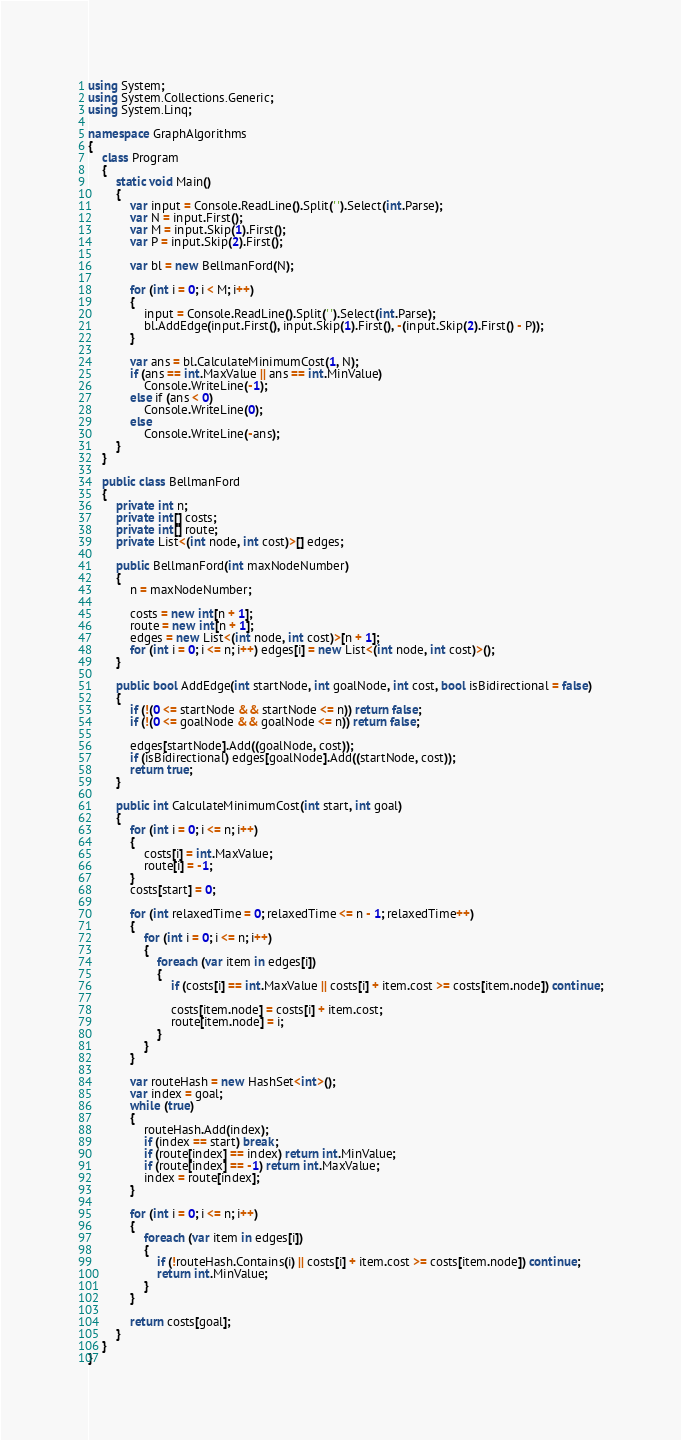Convert code to text. <code><loc_0><loc_0><loc_500><loc_500><_C#_>using System;
using System.Collections.Generic;
using System.Linq;

namespace GraphAlgorithms
{
    class Program
    {
        static void Main()
        {
            var input = Console.ReadLine().Split(' ').Select(int.Parse);
            var N = input.First();
            var M = input.Skip(1).First();
            var P = input.Skip(2).First();

            var bl = new BellmanFord(N);

            for (int i = 0; i < M; i++)
            {
                input = Console.ReadLine().Split(' ').Select(int.Parse);
                bl.AddEdge(input.First(), input.Skip(1).First(), -(input.Skip(2).First() - P));
            }

            var ans = bl.CalculateMinimumCost(1, N);
            if (ans == int.MaxValue || ans == int.MinValue)
                Console.WriteLine(-1);
            else if (ans < 0)
                Console.WriteLine(0);
            else
                Console.WriteLine(-ans);
        }
    }

    public class BellmanFord
    {
        private int n;
        private int[] costs;
        private int[] route;
        private List<(int node, int cost)>[] edges;

        public BellmanFord(int maxNodeNumber)
        {
            n = maxNodeNumber;

            costs = new int[n + 1];
            route = new int[n + 1];
            edges = new List<(int node, int cost)>[n + 1];
            for (int i = 0; i <= n; i++) edges[i] = new List<(int node, int cost)>();
        }

        public bool AddEdge(int startNode, int goalNode, int cost, bool isBidirectional = false)
        {
            if (!(0 <= startNode && startNode <= n)) return false;
            if (!(0 <= goalNode && goalNode <= n)) return false;

            edges[startNode].Add((goalNode, cost));
            if (isBidirectional) edges[goalNode].Add((startNode, cost));
            return true;
        }

        public int CalculateMinimumCost(int start, int goal)
        {
            for (int i = 0; i <= n; i++)
            {
                costs[i] = int.MaxValue;
                route[i] = -1;
            }
            costs[start] = 0;

            for (int relaxedTime = 0; relaxedTime <= n - 1; relaxedTime++)
            {
                for (int i = 0; i <= n; i++)
                {
                    foreach (var item in edges[i])
                    {
                        if (costs[i] == int.MaxValue || costs[i] + item.cost >= costs[item.node]) continue;

                        costs[item.node] = costs[i] + item.cost;
                        route[item.node] = i;
                    }
                }
            }

            var routeHash = new HashSet<int>();
            var index = goal;
            while (true)
            {
                routeHash.Add(index);
                if (index == start) break;
                if (route[index] == index) return int.MinValue;
                if (route[index] == -1) return int.MaxValue;
                index = route[index];
            }

            for (int i = 0; i <= n; i++)
            {
                foreach (var item in edges[i])
                {
                    if (!routeHash.Contains(i) || costs[i] + item.cost >= costs[item.node]) continue;
                    return int.MinValue;
                }
            }

            return costs[goal];
        }
    }
}
</code> 